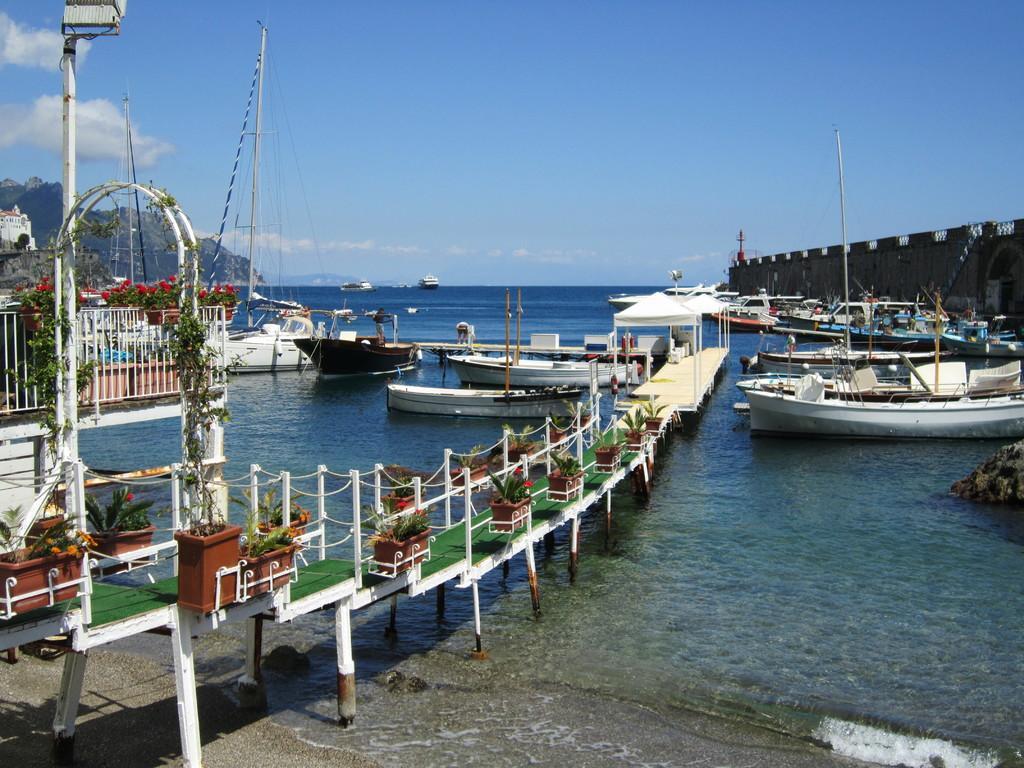How would you summarize this image in a sentence or two? In this image I see the water on which there are number of boats and I see the platform over here on which there are pots on which there are plants and I see flowers which are of red in color and in the background I see the poles and the clear sky and I see a building over here. 